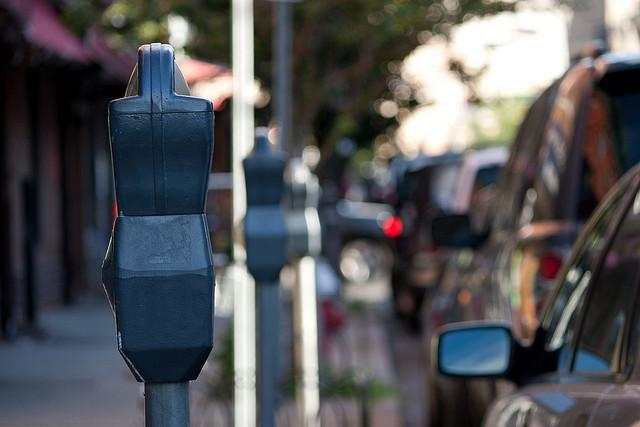What is to the left of the cars? Please explain your reasoning. parking meters. Cars are parked at a device that you put coins in. people do this when they want to park. 